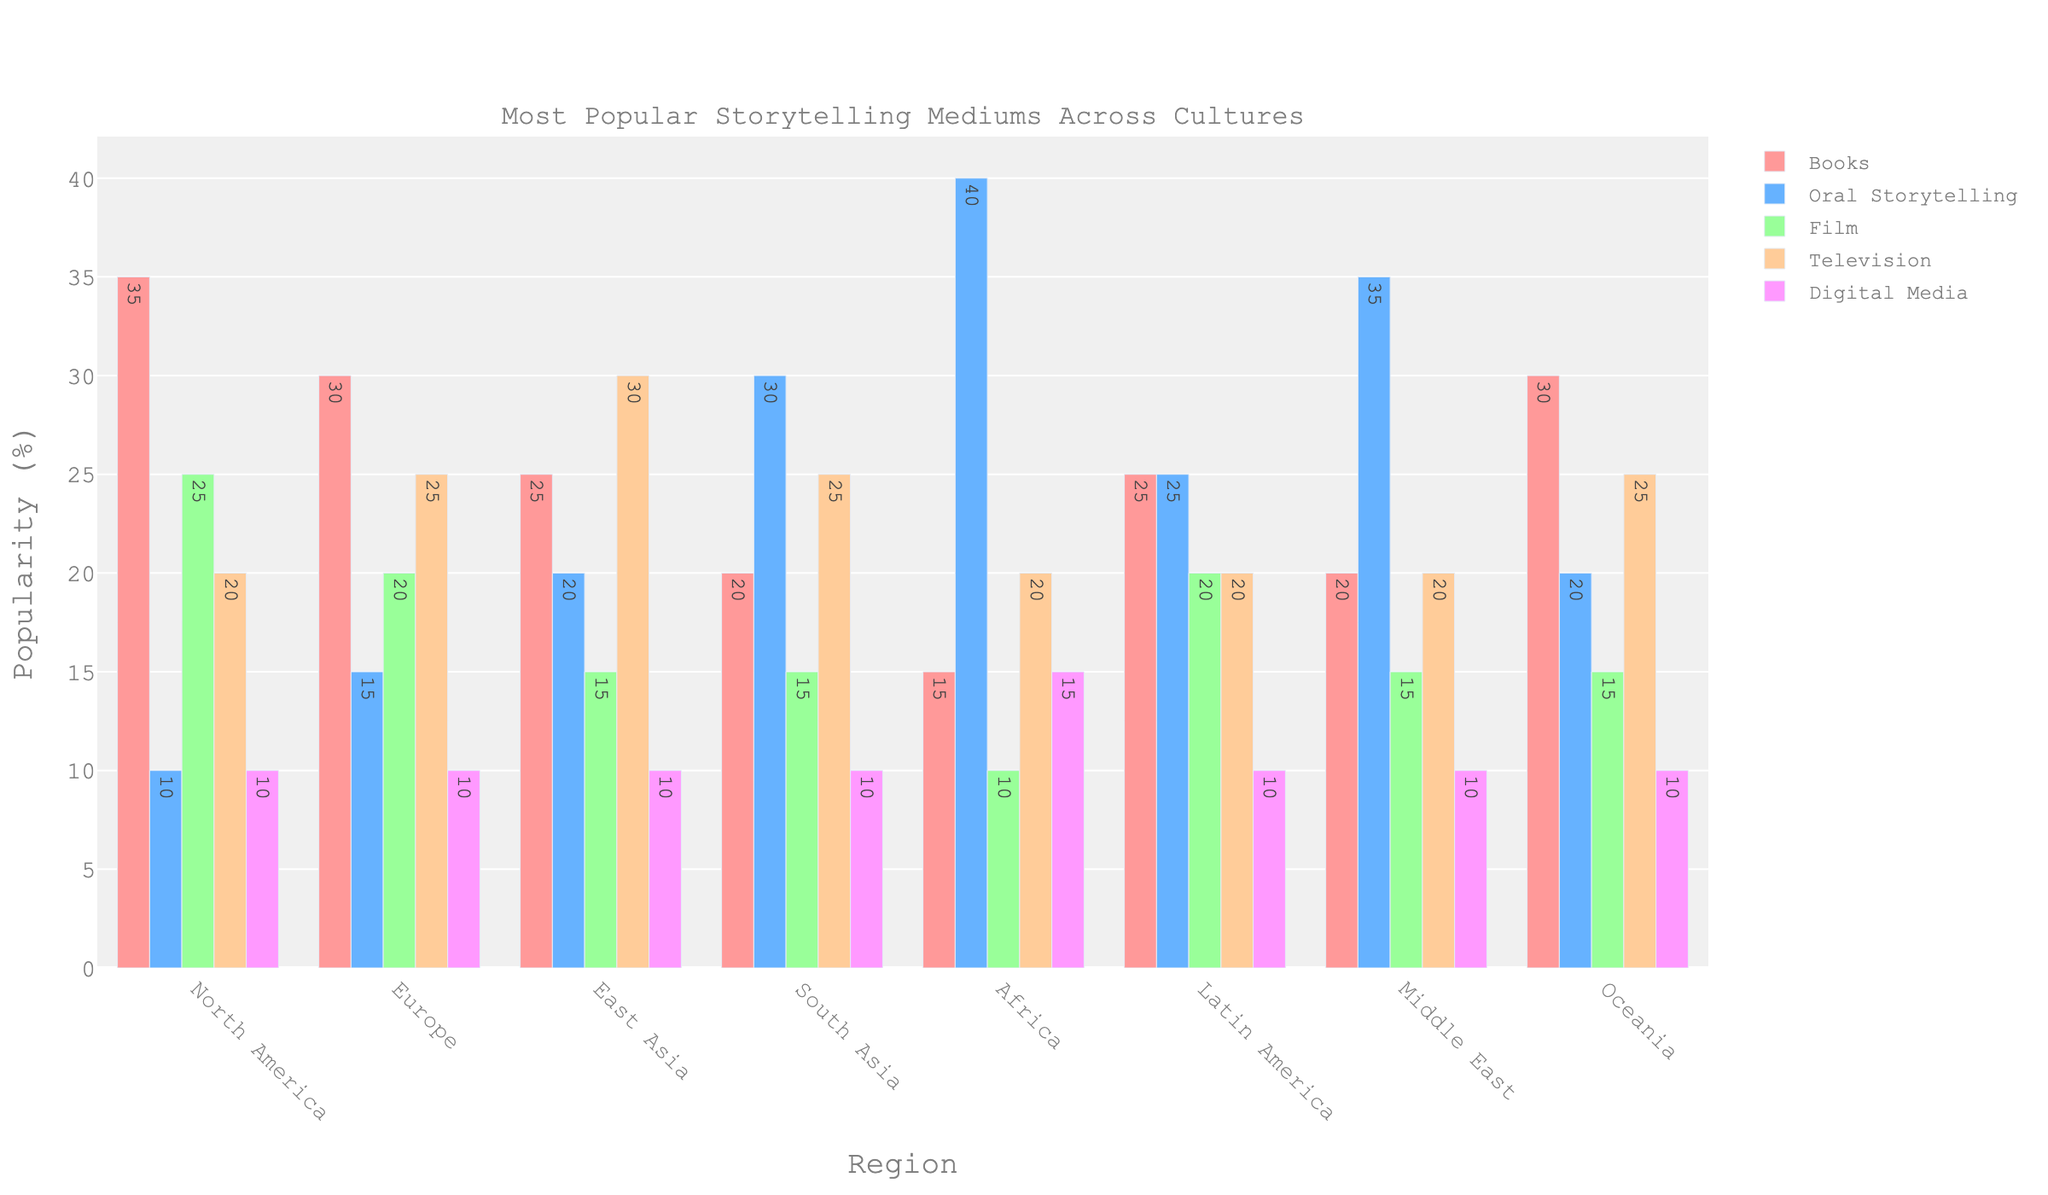Which region has the highest popularity for oral storytelling? To find the region with the highest popularity for oral storytelling, look for the tallest bar in the "Oral Storytelling" category. Africa has the highest value at 40%.
Answer: Africa Which region shows an equal percentage for books and film? Compare the heights of the bars for books and film within each region. North America shows 35% for books and 25% for film, Europe shows 30% for books and 20% for film, East Asia shows 25% for books and 15% for film, South Asia shows 20% for books and 15% for film, Africa shows 15% for books and 10% for film, Latin America shows 25% for books and 20% for film, The Middle East shows 20% for books and 15% for film, and Oceania shows 30% for books and 15% for film. None of the regions have equal percentages for books and film.
Answer: None Which storytelling medium is most popular in South Asia? Observe the bar heights for each medium within South Asia and identify the tallest one. Oral storytelling has the highest value at 30%.
Answer: Oral Storytelling How does the popularity of digital media compare across all regions? Compare the heights of the bars for digital media across all regions. Digital media has consistent values across all, with each region showing 10% except Africa which has 15%.
Answer: Similar across all regions, with Africa slightly higher Which two regions show the highest and lowest popularity for books? Identify the region with the tallest bar for books (North America at 35%) and the region with the shortest bar for books (Africa at 15%).
Answer: North America, Africa What is the combined popularity of television and film in East Asia? Add the values for television and film in East Asia. Television is 30% and film is 15%. 30% + 15% = 45%.
Answer: 45% In Europe, is the popularity of television greater than digital media? Compare the heights of the bars for television and digital media within Europe. Television shows 25% and digital media shows 10%.
Answer: Yes Which region has the least variation in popularity among different mediums? Compare the range of values (difference between highest and lowest) within each region. Based on visual inspection, Oceania has relatively balanced bar heights: 30, 20, 15, 25, and 10.
Answer: Oceania What is the most popular storytelling medium overall in the Middle East? Look for the tallest bar within the Middle East. Oral storytelling has the highest value at 35%.
Answer: Oral Storytelling 